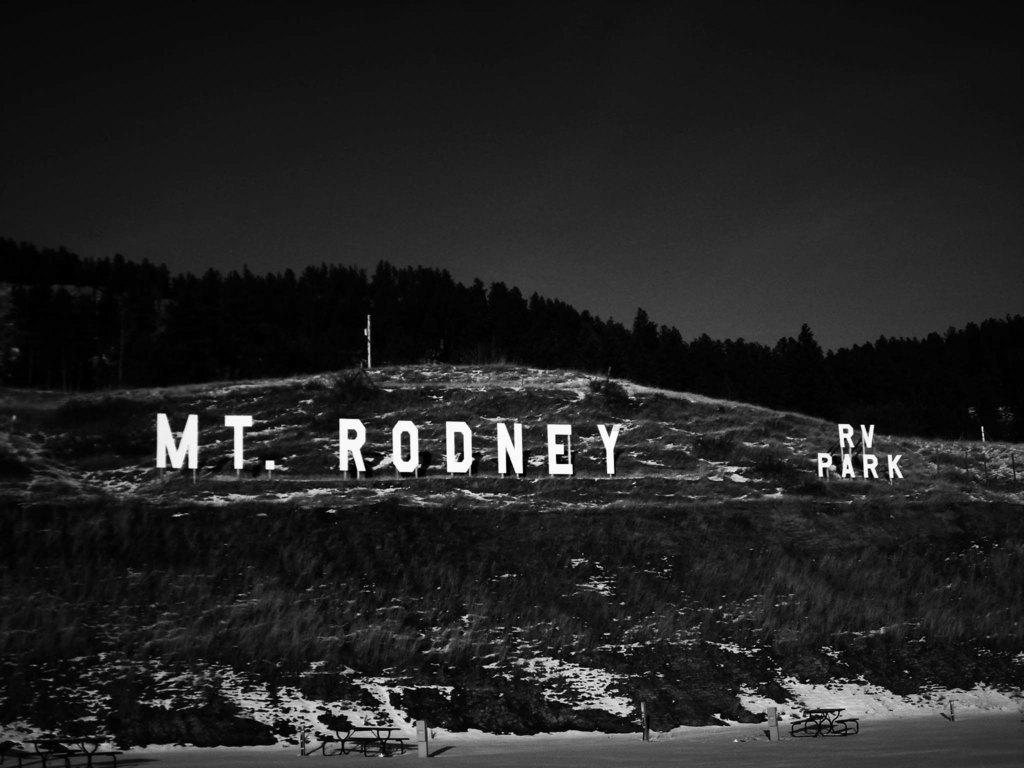<image>
Render a clear and concise summary of the photo. the RV park is advertised as Mt. Rodney 